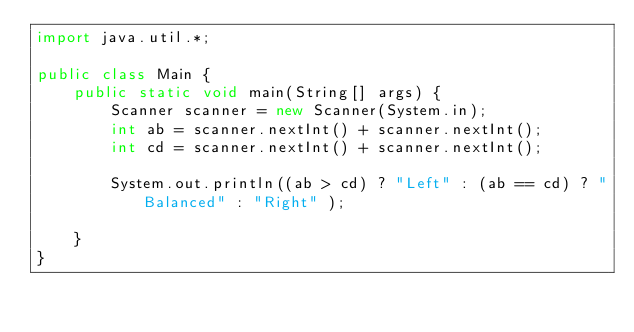<code> <loc_0><loc_0><loc_500><loc_500><_Java_>import java.util.*;

public class Main {
    public static void main(String[] args) {
        Scanner scanner = new Scanner(System.in);
        int ab = scanner.nextInt() + scanner.nextInt();
        int cd = scanner.nextInt() + scanner.nextInt();

        System.out.println((ab > cd) ? "Left" : (ab == cd) ? "Balanced" : "Right" );

    }
}
</code> 